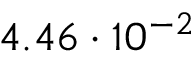Convert formula to latex. <formula><loc_0><loc_0><loc_500><loc_500>4 . 4 6 \cdot 1 0 ^ { - 2 }</formula> 